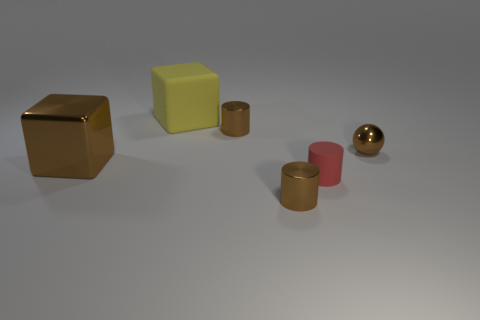How many large things are either blocks or brown metallic cubes? There are two large objects in the image that fit the description: one is a brown metallic cube, and the other is a large yellow block. It's important to classify objects by both their shape and color to accurately address the question. 